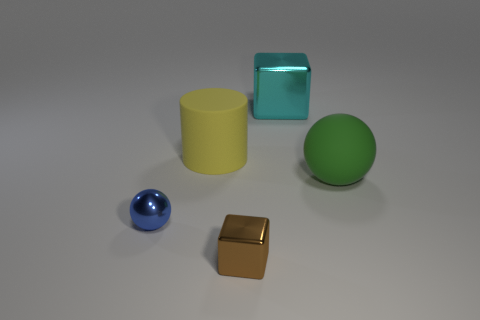Is the material of the brown cube that is in front of the large yellow matte cylinder the same as the blue ball?
Your response must be concise. Yes. What is the color of the tiny block that is the same material as the blue thing?
Provide a short and direct response. Brown. Is the number of big metal objects that are in front of the small ball less than the number of rubber objects behind the brown thing?
Keep it short and to the point. Yes. Are there any other small brown blocks made of the same material as the small block?
Your response must be concise. No. There is a sphere that is to the left of the rubber thing behind the big green matte sphere; how big is it?
Make the answer very short. Small. Is the number of small brown rubber objects greater than the number of small blue things?
Offer a very short reply. No. Is the size of the shiny cube in front of the blue ball the same as the large matte sphere?
Your answer should be very brief. No. Is the large cyan metallic thing the same shape as the yellow matte object?
Provide a short and direct response. No. There is a brown metal thing that is the same shape as the big cyan thing; what size is it?
Ensure brevity in your answer.  Small. Is the number of big yellow things to the left of the large yellow thing greater than the number of brown blocks on the right side of the tiny brown cube?
Provide a short and direct response. No. 